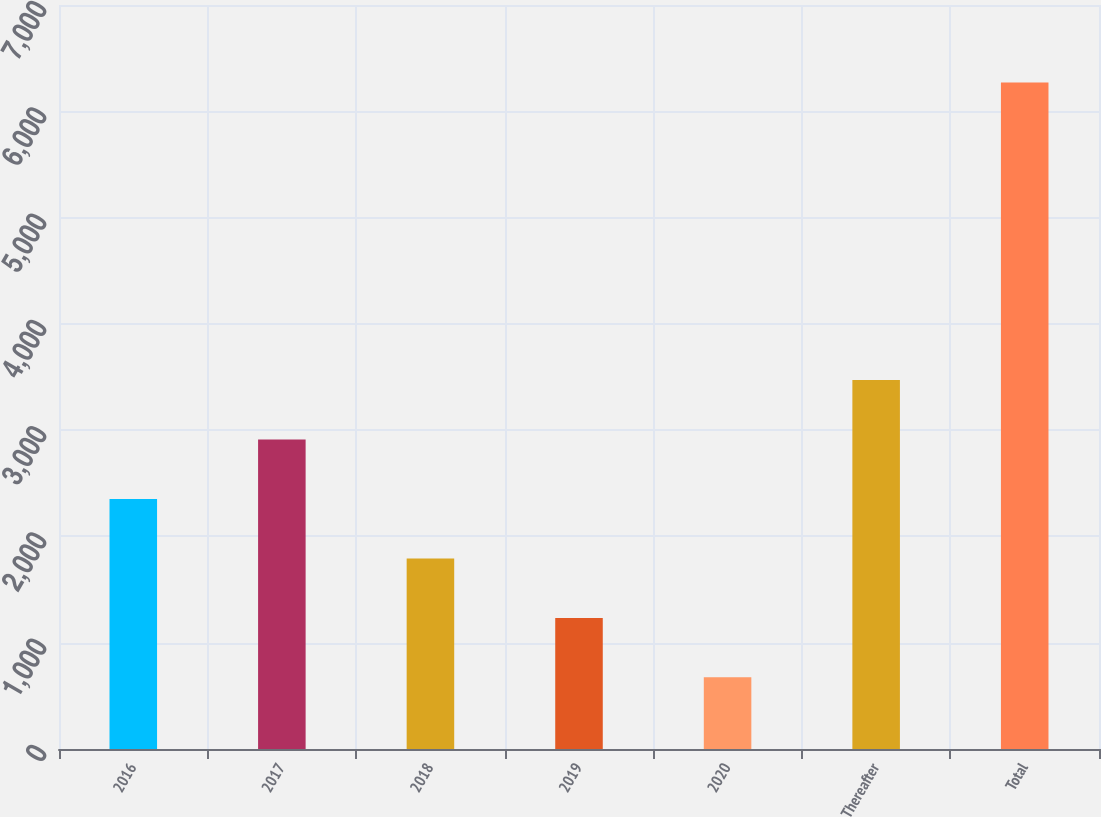<chart> <loc_0><loc_0><loc_500><loc_500><bar_chart><fcel>2016<fcel>2017<fcel>2018<fcel>2019<fcel>2020<fcel>Thereafter<fcel>Total<nl><fcel>2353.1<fcel>2912.8<fcel>1793.4<fcel>1233.7<fcel>674<fcel>3472.5<fcel>6271<nl></chart> 